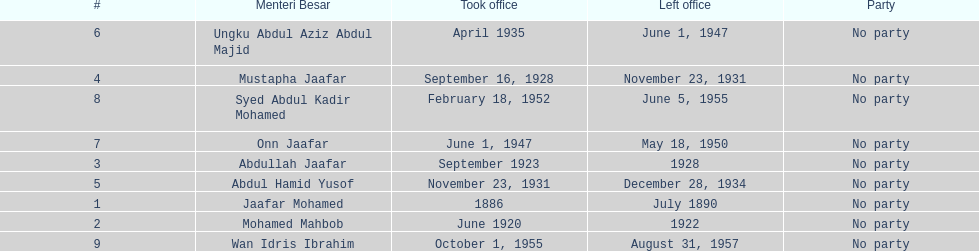Help me parse the entirety of this table. {'header': ['#', 'Menteri Besar', 'Took office', 'Left office', 'Party'], 'rows': [['6', 'Ungku Abdul Aziz Abdul Majid', 'April 1935', 'June 1, 1947', 'No party'], ['4', 'Mustapha Jaafar', 'September 16, 1928', 'November 23, 1931', 'No party'], ['8', 'Syed Abdul Kadir Mohamed', 'February 18, 1952', 'June 5, 1955', 'No party'], ['7', 'Onn Jaafar', 'June 1, 1947', 'May 18, 1950', 'No party'], ['3', 'Abdullah Jaafar', 'September 1923', '1928', 'No party'], ['5', 'Abdul Hamid Yusof', 'November 23, 1931', 'December 28, 1934', 'No party'], ['1', 'Jaafar Mohamed', '1886', 'July 1890', 'No party'], ['2', 'Mohamed Mahbob', 'June 1920', '1922', 'No party'], ['9', 'Wan Idris Ibrahim', 'October 1, 1955', 'August 31, 1957', 'No party']]} Who is listed below onn jaafar? Syed Abdul Kadir Mohamed. 